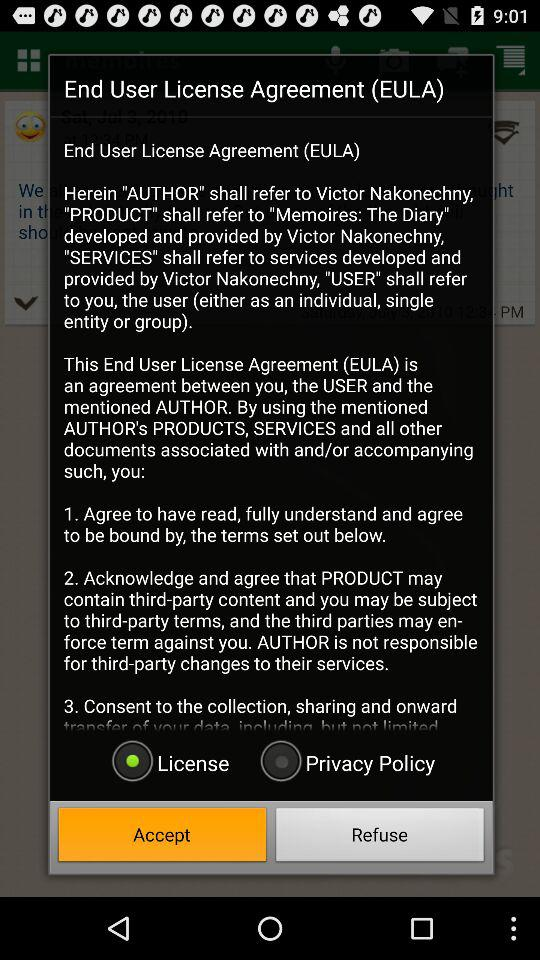How many terms does the agreement have?
Answer the question using a single word or phrase. 3 